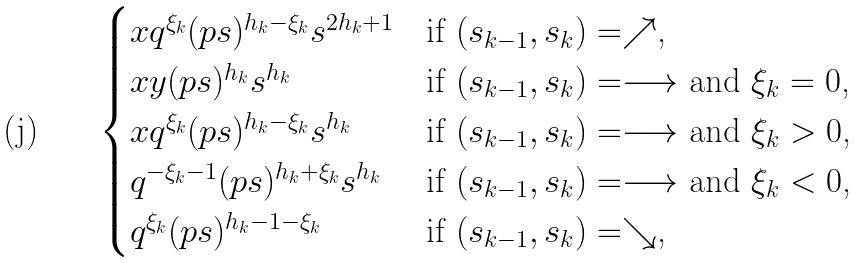Convert formula to latex. <formula><loc_0><loc_0><loc_500><loc_500>\begin{cases} x q ^ { \xi _ { k } } ( p s ) ^ { h _ { k } - { \xi _ { k } } } s ^ { 2 h _ { k } + 1 } & \text {if $(s_{k-1},s_{k})=\nearrow$,} \\ x y ( p s ) ^ { h _ { k } } s ^ { h _ { k } } & \text {if $(s_{k-1},s_{k})=\longrightarrow$ and $\xi_{k}=0$,} \\ x q ^ { \xi _ { k } } ( p s ) ^ { h _ { k } - \xi _ { k } } s ^ { h _ { k } } & \text {if $(s_{k-1},s_{k})=\longrightarrow$ and $\xi_{k}>0$,} \\ q ^ { - \xi _ { k } - 1 } ( p s ) ^ { h _ { k } + { \xi _ { k } } } s ^ { h _ { k } } & \text {if $(s_{k-1},s_{k})=\longrightarrow$ and $\xi_{k}<0$,} \\ q ^ { \xi _ { k } } ( p s ) ^ { h _ { k } - 1 - \xi _ { k } } & \text {if $(s_{k-1},s_{k})=\searrow$,} \end{cases}</formula> 